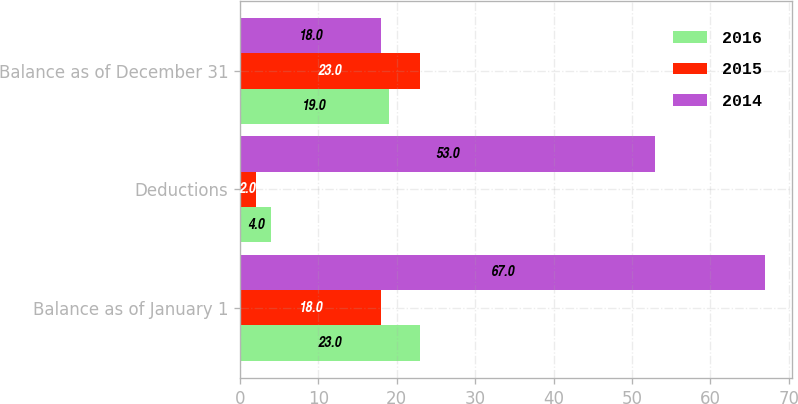Convert chart. <chart><loc_0><loc_0><loc_500><loc_500><stacked_bar_chart><ecel><fcel>Balance as of January 1<fcel>Deductions<fcel>Balance as of December 31<nl><fcel>2016<fcel>23<fcel>4<fcel>19<nl><fcel>2015<fcel>18<fcel>2<fcel>23<nl><fcel>2014<fcel>67<fcel>53<fcel>18<nl></chart> 